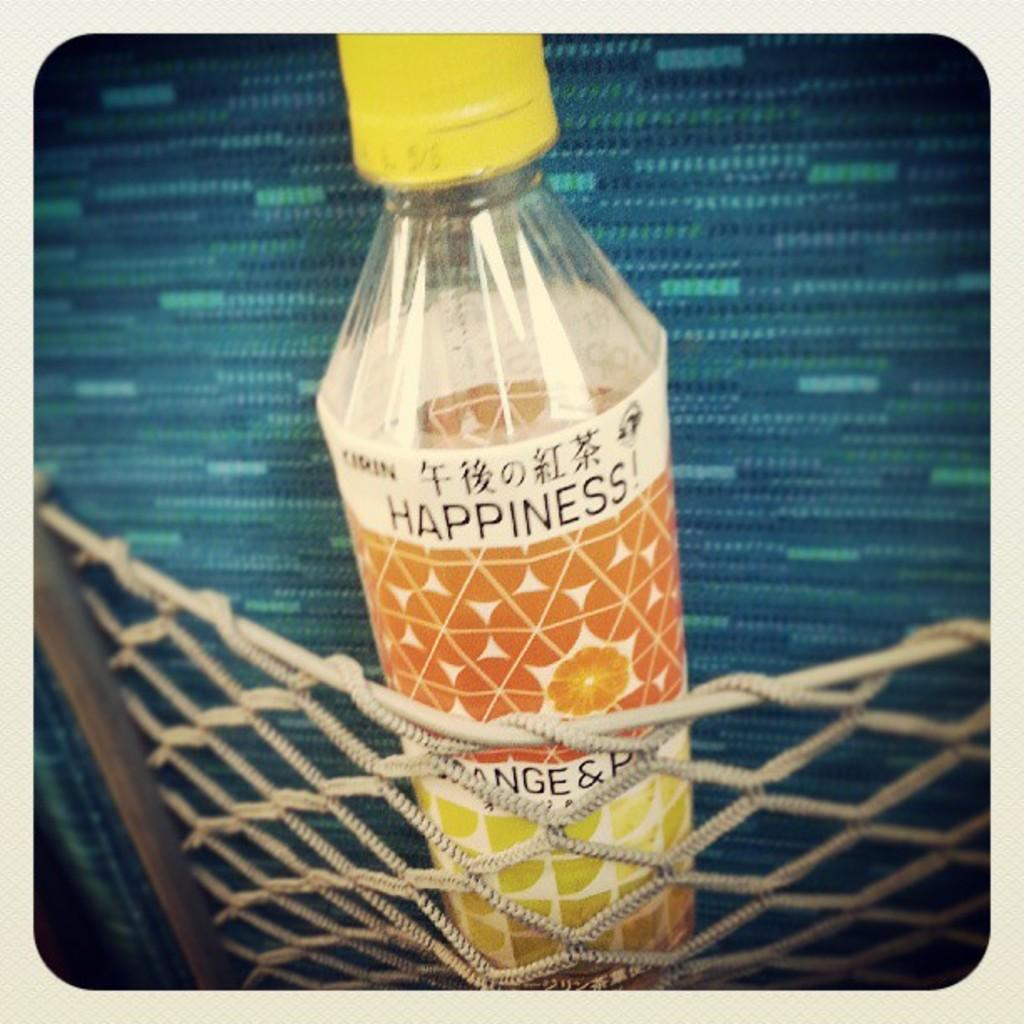<image>
Describe the image concisely. A bottle of HAPPINESS! rests inside of a cargo net. 